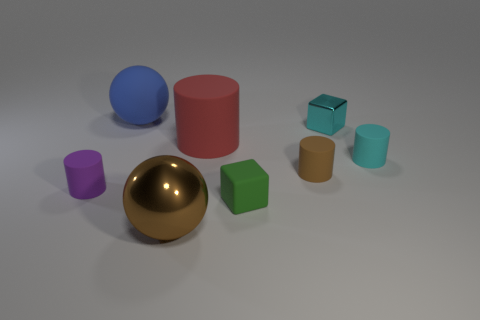Add 1 yellow metal balls. How many objects exist? 9 Subtract all balls. How many objects are left? 6 Add 3 large rubber cylinders. How many large rubber cylinders exist? 4 Subtract 0 blue blocks. How many objects are left? 8 Subtract all small matte cylinders. Subtract all rubber cubes. How many objects are left? 4 Add 4 small green rubber objects. How many small green rubber objects are left? 5 